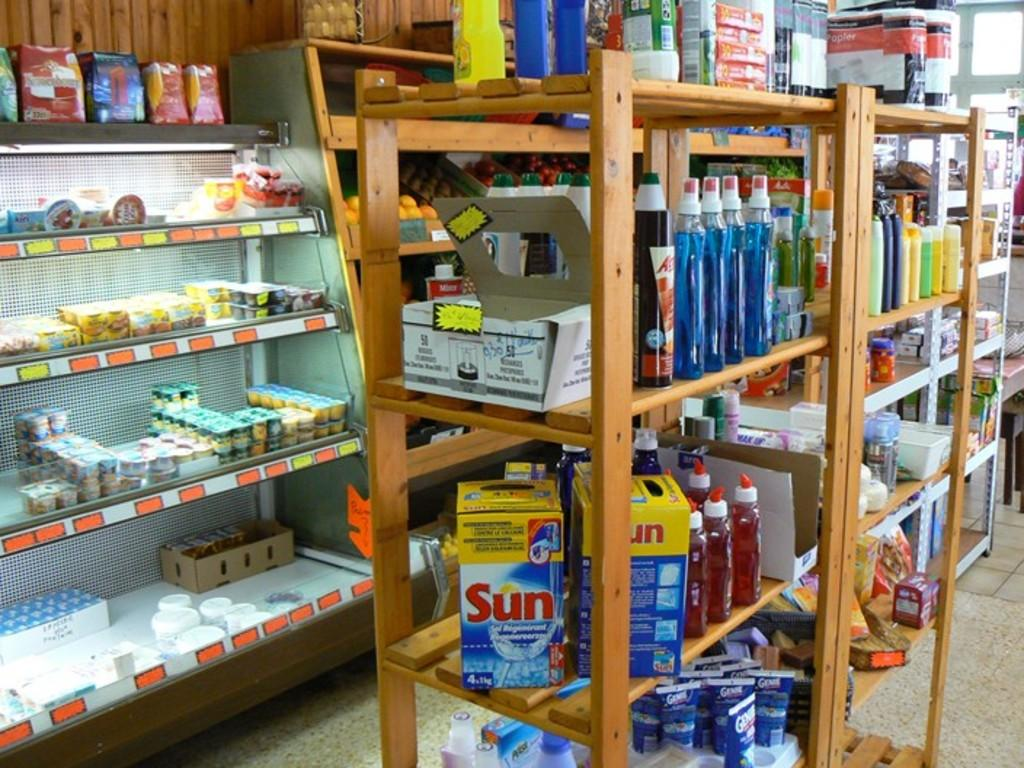<image>
Provide a brief description of the given image. A shelf of household cleaners including Sun detergent. 